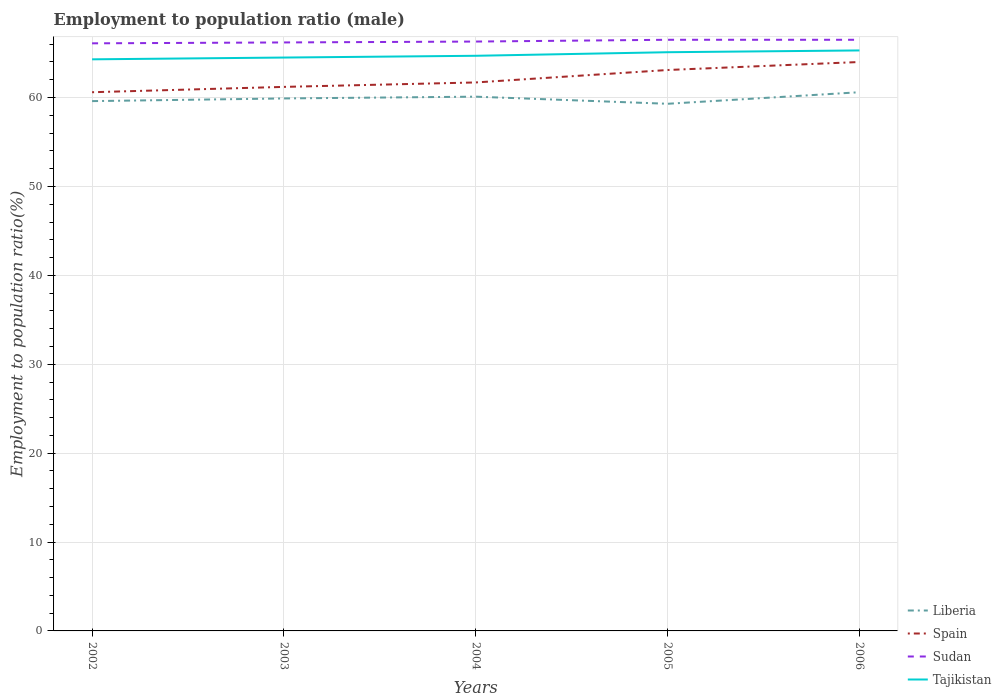How many different coloured lines are there?
Offer a very short reply. 4. Does the line corresponding to Sudan intersect with the line corresponding to Spain?
Keep it short and to the point. No. Across all years, what is the maximum employment to population ratio in Sudan?
Your response must be concise. 66.1. In which year was the employment to population ratio in Spain maximum?
Keep it short and to the point. 2002. What is the total employment to population ratio in Tajikistan in the graph?
Provide a short and direct response. -0.2. What is the difference between the highest and the second highest employment to population ratio in Spain?
Provide a succinct answer. 3.4. Is the employment to population ratio in Spain strictly greater than the employment to population ratio in Sudan over the years?
Make the answer very short. Yes. How many lines are there?
Provide a short and direct response. 4. Are the values on the major ticks of Y-axis written in scientific E-notation?
Provide a succinct answer. No. Does the graph contain grids?
Provide a succinct answer. Yes. How many legend labels are there?
Your answer should be very brief. 4. How are the legend labels stacked?
Your answer should be very brief. Vertical. What is the title of the graph?
Provide a short and direct response. Employment to population ratio (male). Does "Malawi" appear as one of the legend labels in the graph?
Your answer should be compact. No. What is the label or title of the X-axis?
Your answer should be very brief. Years. What is the label or title of the Y-axis?
Your answer should be compact. Employment to population ratio(%). What is the Employment to population ratio(%) in Liberia in 2002?
Provide a succinct answer. 59.6. What is the Employment to population ratio(%) in Spain in 2002?
Ensure brevity in your answer.  60.6. What is the Employment to population ratio(%) in Sudan in 2002?
Offer a very short reply. 66.1. What is the Employment to population ratio(%) of Tajikistan in 2002?
Provide a succinct answer. 64.3. What is the Employment to population ratio(%) of Liberia in 2003?
Your response must be concise. 59.9. What is the Employment to population ratio(%) of Spain in 2003?
Offer a terse response. 61.2. What is the Employment to population ratio(%) of Sudan in 2003?
Keep it short and to the point. 66.2. What is the Employment to population ratio(%) in Tajikistan in 2003?
Your answer should be compact. 64.5. What is the Employment to population ratio(%) in Liberia in 2004?
Give a very brief answer. 60.1. What is the Employment to population ratio(%) in Spain in 2004?
Give a very brief answer. 61.7. What is the Employment to population ratio(%) in Sudan in 2004?
Make the answer very short. 66.3. What is the Employment to population ratio(%) of Tajikistan in 2004?
Provide a short and direct response. 64.7. What is the Employment to population ratio(%) in Liberia in 2005?
Give a very brief answer. 59.3. What is the Employment to population ratio(%) in Spain in 2005?
Provide a succinct answer. 63.1. What is the Employment to population ratio(%) in Sudan in 2005?
Provide a succinct answer. 66.5. What is the Employment to population ratio(%) of Tajikistan in 2005?
Ensure brevity in your answer.  65.1. What is the Employment to population ratio(%) of Liberia in 2006?
Make the answer very short. 60.6. What is the Employment to population ratio(%) in Spain in 2006?
Your answer should be compact. 64. What is the Employment to population ratio(%) in Sudan in 2006?
Make the answer very short. 66.5. What is the Employment to population ratio(%) of Tajikistan in 2006?
Keep it short and to the point. 65.3. Across all years, what is the maximum Employment to population ratio(%) in Liberia?
Offer a terse response. 60.6. Across all years, what is the maximum Employment to population ratio(%) in Sudan?
Make the answer very short. 66.5. Across all years, what is the maximum Employment to population ratio(%) in Tajikistan?
Your response must be concise. 65.3. Across all years, what is the minimum Employment to population ratio(%) of Liberia?
Offer a terse response. 59.3. Across all years, what is the minimum Employment to population ratio(%) of Spain?
Your answer should be compact. 60.6. Across all years, what is the minimum Employment to population ratio(%) of Sudan?
Ensure brevity in your answer.  66.1. Across all years, what is the minimum Employment to population ratio(%) in Tajikistan?
Your answer should be very brief. 64.3. What is the total Employment to population ratio(%) in Liberia in the graph?
Your response must be concise. 299.5. What is the total Employment to population ratio(%) in Spain in the graph?
Give a very brief answer. 310.6. What is the total Employment to population ratio(%) of Sudan in the graph?
Provide a succinct answer. 331.6. What is the total Employment to population ratio(%) in Tajikistan in the graph?
Provide a short and direct response. 323.9. What is the difference between the Employment to population ratio(%) of Spain in 2002 and that in 2003?
Provide a succinct answer. -0.6. What is the difference between the Employment to population ratio(%) in Sudan in 2002 and that in 2003?
Ensure brevity in your answer.  -0.1. What is the difference between the Employment to population ratio(%) of Liberia in 2002 and that in 2005?
Make the answer very short. 0.3. What is the difference between the Employment to population ratio(%) of Spain in 2002 and that in 2005?
Ensure brevity in your answer.  -2.5. What is the difference between the Employment to population ratio(%) of Sudan in 2002 and that in 2005?
Provide a succinct answer. -0.4. What is the difference between the Employment to population ratio(%) in Tajikistan in 2002 and that in 2006?
Your response must be concise. -1. What is the difference between the Employment to population ratio(%) in Tajikistan in 2003 and that in 2004?
Give a very brief answer. -0.2. What is the difference between the Employment to population ratio(%) of Liberia in 2003 and that in 2005?
Your answer should be compact. 0.6. What is the difference between the Employment to population ratio(%) of Tajikistan in 2003 and that in 2005?
Your response must be concise. -0.6. What is the difference between the Employment to population ratio(%) in Spain in 2003 and that in 2006?
Ensure brevity in your answer.  -2.8. What is the difference between the Employment to population ratio(%) in Tajikistan in 2003 and that in 2006?
Provide a short and direct response. -0.8. What is the difference between the Employment to population ratio(%) of Liberia in 2004 and that in 2005?
Offer a very short reply. 0.8. What is the difference between the Employment to population ratio(%) in Spain in 2004 and that in 2005?
Keep it short and to the point. -1.4. What is the difference between the Employment to population ratio(%) in Tajikistan in 2004 and that in 2005?
Your answer should be very brief. -0.4. What is the difference between the Employment to population ratio(%) in Liberia in 2004 and that in 2006?
Keep it short and to the point. -0.5. What is the difference between the Employment to population ratio(%) of Spain in 2004 and that in 2006?
Your answer should be compact. -2.3. What is the difference between the Employment to population ratio(%) of Spain in 2005 and that in 2006?
Offer a very short reply. -0.9. What is the difference between the Employment to population ratio(%) in Tajikistan in 2005 and that in 2006?
Offer a very short reply. -0.2. What is the difference between the Employment to population ratio(%) of Liberia in 2002 and the Employment to population ratio(%) of Sudan in 2003?
Offer a terse response. -6.6. What is the difference between the Employment to population ratio(%) of Liberia in 2002 and the Employment to population ratio(%) of Tajikistan in 2003?
Provide a short and direct response. -4.9. What is the difference between the Employment to population ratio(%) in Spain in 2002 and the Employment to population ratio(%) in Tajikistan in 2003?
Your response must be concise. -3.9. What is the difference between the Employment to population ratio(%) of Sudan in 2002 and the Employment to population ratio(%) of Tajikistan in 2003?
Your response must be concise. 1.6. What is the difference between the Employment to population ratio(%) in Liberia in 2002 and the Employment to population ratio(%) in Spain in 2004?
Your answer should be very brief. -2.1. What is the difference between the Employment to population ratio(%) of Spain in 2002 and the Employment to population ratio(%) of Sudan in 2004?
Keep it short and to the point. -5.7. What is the difference between the Employment to population ratio(%) in Sudan in 2002 and the Employment to population ratio(%) in Tajikistan in 2004?
Ensure brevity in your answer.  1.4. What is the difference between the Employment to population ratio(%) of Liberia in 2002 and the Employment to population ratio(%) of Sudan in 2005?
Your response must be concise. -6.9. What is the difference between the Employment to population ratio(%) in Spain in 2002 and the Employment to population ratio(%) in Sudan in 2005?
Your answer should be very brief. -5.9. What is the difference between the Employment to population ratio(%) of Liberia in 2002 and the Employment to population ratio(%) of Spain in 2006?
Give a very brief answer. -4.4. What is the difference between the Employment to population ratio(%) in Liberia in 2002 and the Employment to population ratio(%) in Sudan in 2006?
Keep it short and to the point. -6.9. What is the difference between the Employment to population ratio(%) in Spain in 2002 and the Employment to population ratio(%) in Tajikistan in 2006?
Keep it short and to the point. -4.7. What is the difference between the Employment to population ratio(%) of Liberia in 2003 and the Employment to population ratio(%) of Tajikistan in 2004?
Give a very brief answer. -4.8. What is the difference between the Employment to population ratio(%) of Spain in 2003 and the Employment to population ratio(%) of Sudan in 2004?
Ensure brevity in your answer.  -5.1. What is the difference between the Employment to population ratio(%) of Sudan in 2003 and the Employment to population ratio(%) of Tajikistan in 2004?
Make the answer very short. 1.5. What is the difference between the Employment to population ratio(%) of Liberia in 2003 and the Employment to population ratio(%) of Sudan in 2005?
Ensure brevity in your answer.  -6.6. What is the difference between the Employment to population ratio(%) in Liberia in 2003 and the Employment to population ratio(%) in Tajikistan in 2005?
Your response must be concise. -5.2. What is the difference between the Employment to population ratio(%) of Spain in 2003 and the Employment to population ratio(%) of Sudan in 2005?
Provide a succinct answer. -5.3. What is the difference between the Employment to population ratio(%) in Spain in 2003 and the Employment to population ratio(%) in Tajikistan in 2005?
Keep it short and to the point. -3.9. What is the difference between the Employment to population ratio(%) of Sudan in 2003 and the Employment to population ratio(%) of Tajikistan in 2005?
Give a very brief answer. 1.1. What is the difference between the Employment to population ratio(%) in Liberia in 2003 and the Employment to population ratio(%) in Spain in 2006?
Your answer should be compact. -4.1. What is the difference between the Employment to population ratio(%) in Liberia in 2003 and the Employment to population ratio(%) in Sudan in 2006?
Offer a very short reply. -6.6. What is the difference between the Employment to population ratio(%) in Spain in 2003 and the Employment to population ratio(%) in Sudan in 2006?
Ensure brevity in your answer.  -5.3. What is the difference between the Employment to population ratio(%) in Liberia in 2004 and the Employment to population ratio(%) in Spain in 2005?
Your answer should be very brief. -3. What is the difference between the Employment to population ratio(%) of Spain in 2004 and the Employment to population ratio(%) of Tajikistan in 2005?
Your answer should be very brief. -3.4. What is the difference between the Employment to population ratio(%) of Sudan in 2004 and the Employment to population ratio(%) of Tajikistan in 2005?
Your answer should be very brief. 1.2. What is the difference between the Employment to population ratio(%) in Liberia in 2004 and the Employment to population ratio(%) in Spain in 2006?
Give a very brief answer. -3.9. What is the difference between the Employment to population ratio(%) in Liberia in 2004 and the Employment to population ratio(%) in Sudan in 2006?
Your answer should be compact. -6.4. What is the difference between the Employment to population ratio(%) in Liberia in 2004 and the Employment to population ratio(%) in Tajikistan in 2006?
Your response must be concise. -5.2. What is the difference between the Employment to population ratio(%) in Spain in 2004 and the Employment to population ratio(%) in Sudan in 2006?
Provide a short and direct response. -4.8. What is the difference between the Employment to population ratio(%) in Spain in 2004 and the Employment to population ratio(%) in Tajikistan in 2006?
Ensure brevity in your answer.  -3.6. What is the difference between the Employment to population ratio(%) in Liberia in 2005 and the Employment to population ratio(%) in Spain in 2006?
Make the answer very short. -4.7. What is the difference between the Employment to population ratio(%) of Liberia in 2005 and the Employment to population ratio(%) of Tajikistan in 2006?
Your response must be concise. -6. What is the difference between the Employment to population ratio(%) of Spain in 2005 and the Employment to population ratio(%) of Sudan in 2006?
Your answer should be very brief. -3.4. What is the difference between the Employment to population ratio(%) in Spain in 2005 and the Employment to population ratio(%) in Tajikistan in 2006?
Your answer should be compact. -2.2. What is the difference between the Employment to population ratio(%) of Sudan in 2005 and the Employment to population ratio(%) of Tajikistan in 2006?
Your answer should be very brief. 1.2. What is the average Employment to population ratio(%) of Liberia per year?
Offer a terse response. 59.9. What is the average Employment to population ratio(%) of Spain per year?
Offer a very short reply. 62.12. What is the average Employment to population ratio(%) in Sudan per year?
Keep it short and to the point. 66.32. What is the average Employment to population ratio(%) of Tajikistan per year?
Provide a short and direct response. 64.78. In the year 2002, what is the difference between the Employment to population ratio(%) of Liberia and Employment to population ratio(%) of Spain?
Offer a very short reply. -1. In the year 2002, what is the difference between the Employment to population ratio(%) in Liberia and Employment to population ratio(%) in Sudan?
Your response must be concise. -6.5. In the year 2002, what is the difference between the Employment to population ratio(%) in Liberia and Employment to population ratio(%) in Tajikistan?
Your response must be concise. -4.7. In the year 2002, what is the difference between the Employment to population ratio(%) of Spain and Employment to population ratio(%) of Sudan?
Your answer should be very brief. -5.5. In the year 2002, what is the difference between the Employment to population ratio(%) in Spain and Employment to population ratio(%) in Tajikistan?
Keep it short and to the point. -3.7. In the year 2002, what is the difference between the Employment to population ratio(%) in Sudan and Employment to population ratio(%) in Tajikistan?
Give a very brief answer. 1.8. In the year 2003, what is the difference between the Employment to population ratio(%) in Sudan and Employment to population ratio(%) in Tajikistan?
Your answer should be very brief. 1.7. In the year 2004, what is the difference between the Employment to population ratio(%) in Liberia and Employment to population ratio(%) in Spain?
Offer a terse response. -1.6. In the year 2004, what is the difference between the Employment to population ratio(%) in Spain and Employment to population ratio(%) in Tajikistan?
Provide a short and direct response. -3. In the year 2004, what is the difference between the Employment to population ratio(%) of Sudan and Employment to population ratio(%) of Tajikistan?
Your answer should be compact. 1.6. In the year 2005, what is the difference between the Employment to population ratio(%) of Liberia and Employment to population ratio(%) of Spain?
Offer a very short reply. -3.8. In the year 2005, what is the difference between the Employment to population ratio(%) of Liberia and Employment to population ratio(%) of Tajikistan?
Your response must be concise. -5.8. In the year 2005, what is the difference between the Employment to population ratio(%) of Spain and Employment to population ratio(%) of Sudan?
Your response must be concise. -3.4. In the year 2005, what is the difference between the Employment to population ratio(%) of Spain and Employment to population ratio(%) of Tajikistan?
Offer a terse response. -2. In the year 2005, what is the difference between the Employment to population ratio(%) of Sudan and Employment to population ratio(%) of Tajikistan?
Your answer should be compact. 1.4. In the year 2006, what is the difference between the Employment to population ratio(%) in Liberia and Employment to population ratio(%) in Spain?
Ensure brevity in your answer.  -3.4. In the year 2006, what is the difference between the Employment to population ratio(%) in Spain and Employment to population ratio(%) in Tajikistan?
Keep it short and to the point. -1.3. In the year 2006, what is the difference between the Employment to population ratio(%) of Sudan and Employment to population ratio(%) of Tajikistan?
Provide a short and direct response. 1.2. What is the ratio of the Employment to population ratio(%) in Liberia in 2002 to that in 2003?
Your answer should be compact. 0.99. What is the ratio of the Employment to population ratio(%) of Spain in 2002 to that in 2003?
Offer a terse response. 0.99. What is the ratio of the Employment to population ratio(%) in Sudan in 2002 to that in 2003?
Ensure brevity in your answer.  1. What is the ratio of the Employment to population ratio(%) of Tajikistan in 2002 to that in 2003?
Your answer should be very brief. 1. What is the ratio of the Employment to population ratio(%) in Spain in 2002 to that in 2004?
Your answer should be very brief. 0.98. What is the ratio of the Employment to population ratio(%) of Sudan in 2002 to that in 2004?
Give a very brief answer. 1. What is the ratio of the Employment to population ratio(%) in Tajikistan in 2002 to that in 2004?
Offer a very short reply. 0.99. What is the ratio of the Employment to population ratio(%) in Spain in 2002 to that in 2005?
Give a very brief answer. 0.96. What is the ratio of the Employment to population ratio(%) of Sudan in 2002 to that in 2005?
Provide a succinct answer. 0.99. What is the ratio of the Employment to population ratio(%) of Liberia in 2002 to that in 2006?
Provide a succinct answer. 0.98. What is the ratio of the Employment to population ratio(%) of Spain in 2002 to that in 2006?
Provide a short and direct response. 0.95. What is the ratio of the Employment to population ratio(%) in Sudan in 2002 to that in 2006?
Provide a short and direct response. 0.99. What is the ratio of the Employment to population ratio(%) in Tajikistan in 2002 to that in 2006?
Your answer should be very brief. 0.98. What is the ratio of the Employment to population ratio(%) in Spain in 2003 to that in 2004?
Offer a terse response. 0.99. What is the ratio of the Employment to population ratio(%) in Sudan in 2003 to that in 2004?
Make the answer very short. 1. What is the ratio of the Employment to population ratio(%) of Tajikistan in 2003 to that in 2004?
Offer a very short reply. 1. What is the ratio of the Employment to population ratio(%) of Liberia in 2003 to that in 2005?
Offer a terse response. 1.01. What is the ratio of the Employment to population ratio(%) in Spain in 2003 to that in 2005?
Your answer should be compact. 0.97. What is the ratio of the Employment to population ratio(%) in Sudan in 2003 to that in 2005?
Your answer should be very brief. 1. What is the ratio of the Employment to population ratio(%) in Tajikistan in 2003 to that in 2005?
Make the answer very short. 0.99. What is the ratio of the Employment to population ratio(%) of Liberia in 2003 to that in 2006?
Offer a very short reply. 0.99. What is the ratio of the Employment to population ratio(%) of Spain in 2003 to that in 2006?
Keep it short and to the point. 0.96. What is the ratio of the Employment to population ratio(%) of Sudan in 2003 to that in 2006?
Provide a succinct answer. 1. What is the ratio of the Employment to population ratio(%) in Tajikistan in 2003 to that in 2006?
Your answer should be compact. 0.99. What is the ratio of the Employment to population ratio(%) of Liberia in 2004 to that in 2005?
Your answer should be very brief. 1.01. What is the ratio of the Employment to population ratio(%) in Spain in 2004 to that in 2005?
Ensure brevity in your answer.  0.98. What is the ratio of the Employment to population ratio(%) of Liberia in 2004 to that in 2006?
Your answer should be compact. 0.99. What is the ratio of the Employment to population ratio(%) in Spain in 2004 to that in 2006?
Your answer should be compact. 0.96. What is the ratio of the Employment to population ratio(%) in Sudan in 2004 to that in 2006?
Provide a short and direct response. 1. What is the ratio of the Employment to population ratio(%) of Liberia in 2005 to that in 2006?
Offer a very short reply. 0.98. What is the ratio of the Employment to population ratio(%) in Spain in 2005 to that in 2006?
Provide a succinct answer. 0.99. What is the ratio of the Employment to population ratio(%) in Sudan in 2005 to that in 2006?
Your response must be concise. 1. What is the ratio of the Employment to population ratio(%) in Tajikistan in 2005 to that in 2006?
Your answer should be very brief. 1. What is the difference between the highest and the second highest Employment to population ratio(%) in Spain?
Your answer should be very brief. 0.9. What is the difference between the highest and the second highest Employment to population ratio(%) in Sudan?
Provide a succinct answer. 0. What is the difference between the highest and the lowest Employment to population ratio(%) in Liberia?
Provide a succinct answer. 1.3. What is the difference between the highest and the lowest Employment to population ratio(%) of Spain?
Provide a succinct answer. 3.4. 